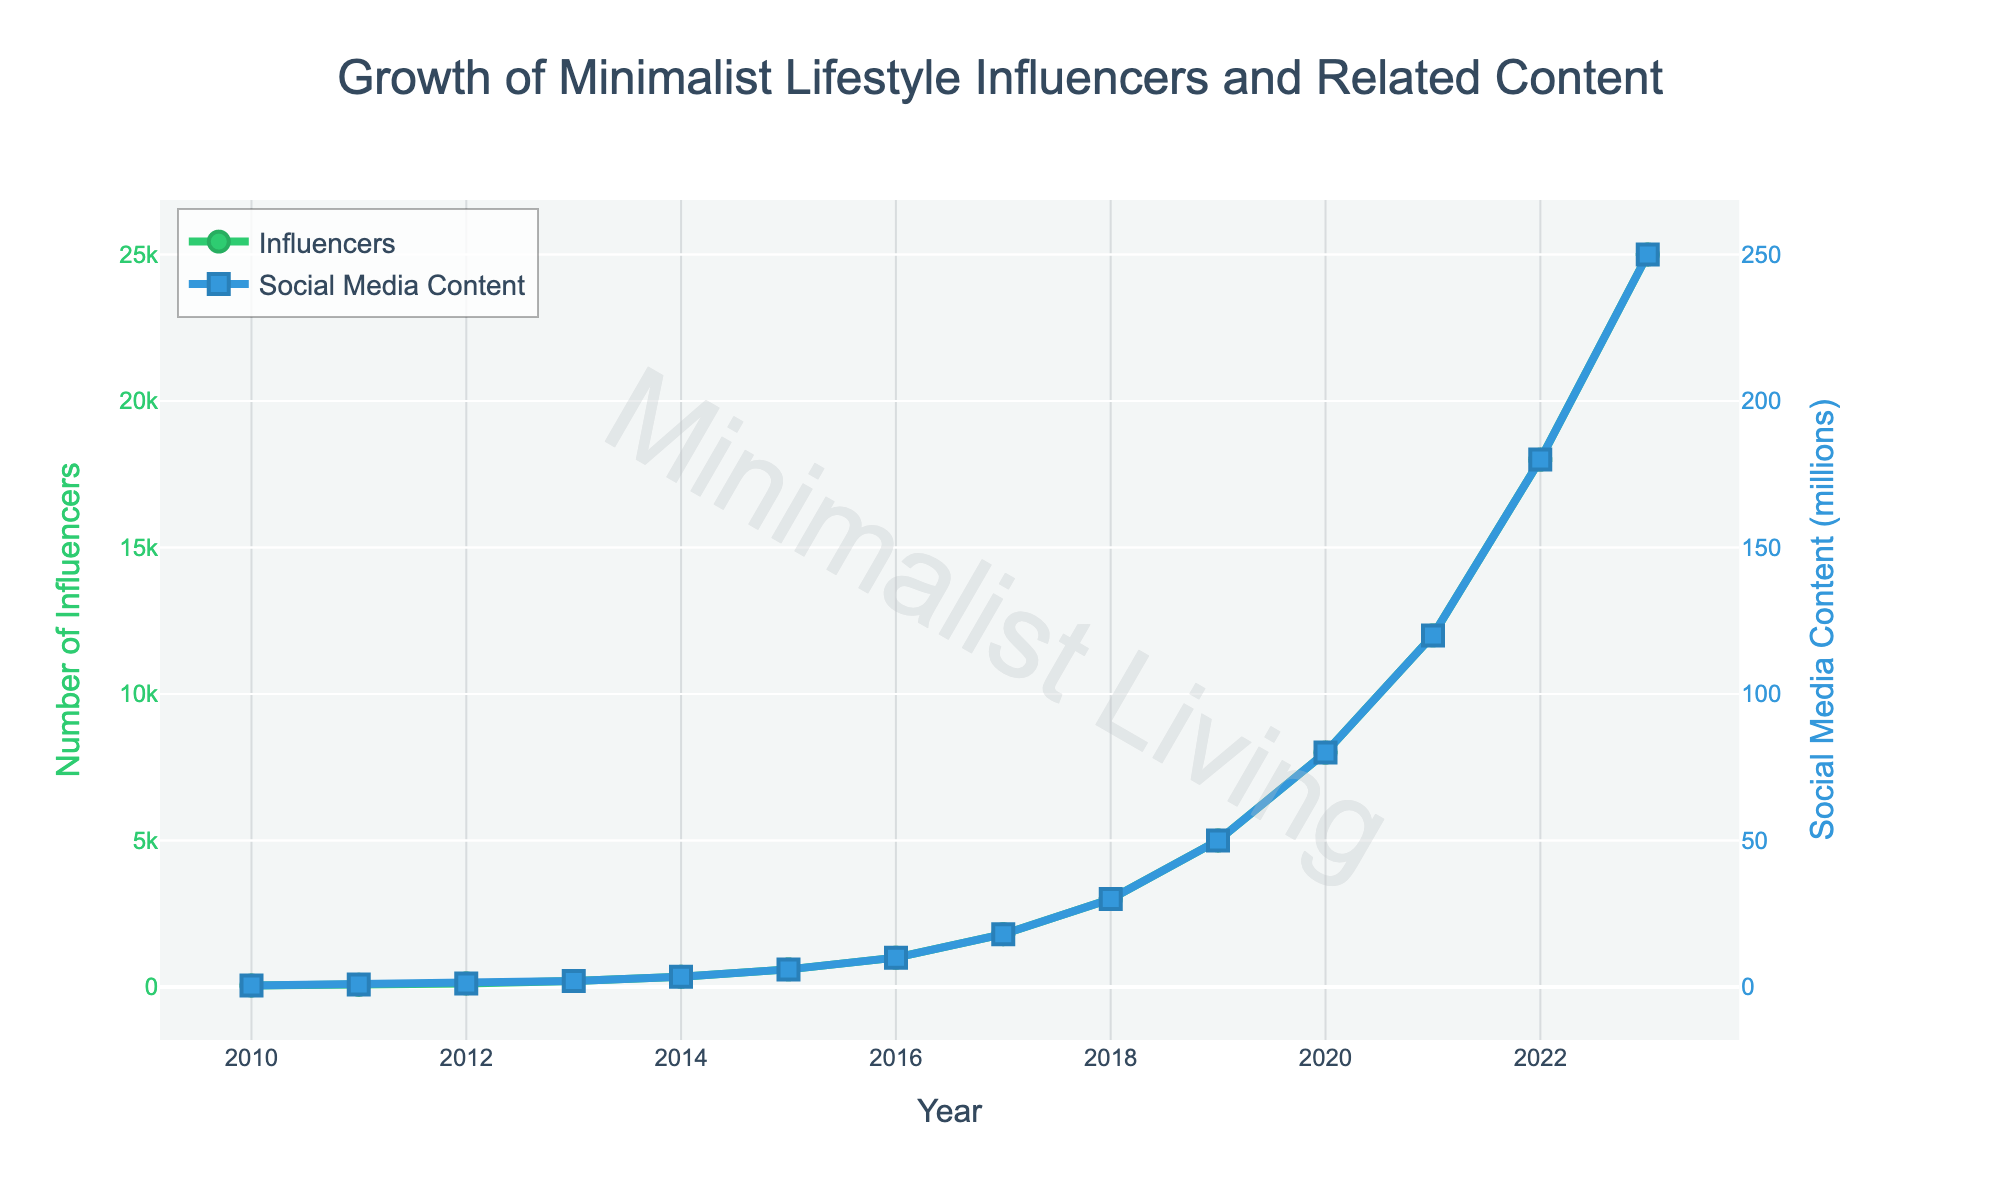How has the number of minimalist lifestyle influencers changed from 2010 to 2023? The number of minimalist lifestyle influencers increased significantly from 50 in 2010 to 25,000 in 2023.
Answer: Increased from 50 to 25,000 How many more influencers were there in 2016 compared to 2014? In 2016, there were 1,000 influencers, and in 2014, there were 350. The difference is 1,000 - 350 = 650.
Answer: 650 By how much did social media content related to minimalist lifestyle increase from 2011 to 2019? Social media content related to minimalist lifestyle increased from 0.8 million in 2011 to 50 million in 2019. The increase is 50 - 0.8 = 49.2 million.
Answer: 49.2 million During which years did the number of influencers see the highest increase? The number of influencers saw the highest increase between 2020 and 2023. The increase was from 8,000 in 2020 to 25,000 in 2023.
Answer: 2020 to 2023 Which year saw a greater increase in related social media content, 2016 or 2017? In 2016, the social media content increased from 6 million (2015) to 10 million – an increase of 4 million. In 2017, it increased from 10 million (2016) to 18 million – an increase of 8 million.
Answer: 2017 What is the total number of influencers added from 2015 to 2020? From 2015 to 2020, influencers increased from 600 to 8,000. The total number added is 8,000 - 600 = 7,400.
Answer: 7,400 Compare the growth rates of influencers and social media content from 2010 to 2023. From 2010 to 2023, influencers increased from 50 to 25,000, which is a growth rate of (25,000/50 - 1) x 100%. Social media content increased from 0.5 million to 250 million, which is a growth rate of (250/0.5 - 1) x 100%. Both growth rates are 49,900%.
Answer: Both have equal growth rates What percentage of the current total related social media content was added in the last three years? The total related social media content in 2023 is 250 million. In the last three years, an increase from 80 million (2020) to 250 million is 170 million. The percentage is (170/250) x 100% = 68%.
Answer: 68% What is the average number of influencers from 2018 to 2021? The number of influencers are 3,000 in 2018, 5,000 in 2019, 8,000 in 2020, and 12,000 in 2021. The average is (3,000 + 5,000 + 8,000 + 12,000) / 4 = 7,000.
Answer: 7,000 